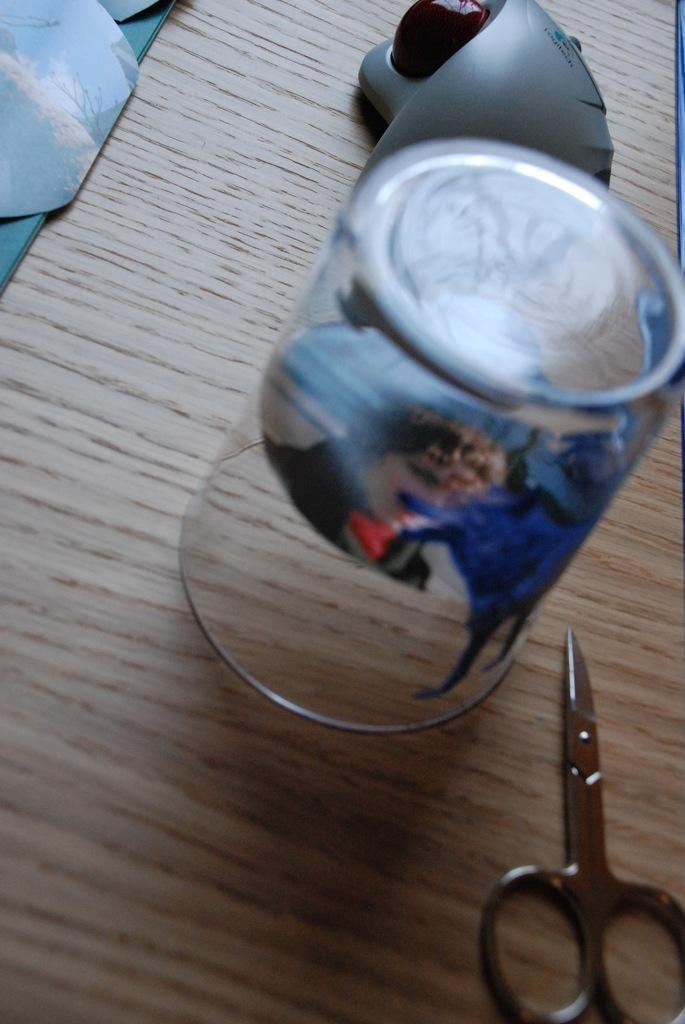What type of container is visible in the image? There is a glass in the image. What other object can be seen in the image? There are scissors in the image. Can you describe the placement of an object in the image? There is an object placed on a wooden thing in the image. How does the team use the tin in the image? There is no team or tin present in the image. What type of pull can be seen in the image? There is no pull present in the image. 